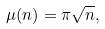Convert formula to latex. <formula><loc_0><loc_0><loc_500><loc_500>\mu ( n ) = \pi \sqrt { n } ,</formula> 